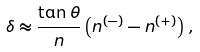<formula> <loc_0><loc_0><loc_500><loc_500>\delta \approx \frac { \tan \theta } { n } \left ( n ^ { ( - ) } - n ^ { ( + ) } \right ) \, ,</formula> 